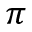<formula> <loc_0><loc_0><loc_500><loc_500>\pi</formula> 